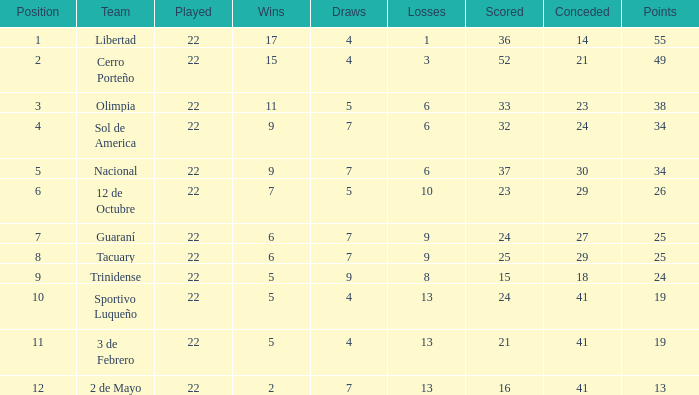Help me parse the entirety of this table. {'header': ['Position', 'Team', 'Played', 'Wins', 'Draws', 'Losses', 'Scored', 'Conceded', 'Points'], 'rows': [['1', 'Libertad', '22', '17', '4', '1', '36', '14', '55'], ['2', 'Cerro Porteño', '22', '15', '4', '3', '52', '21', '49'], ['3', 'Olimpia', '22', '11', '5', '6', '33', '23', '38'], ['4', 'Sol de America', '22', '9', '7', '6', '32', '24', '34'], ['5', 'Nacional', '22', '9', '7', '6', '37', '30', '34'], ['6', '12 de Octubre', '22', '7', '5', '10', '23', '29', '26'], ['7', 'Guaraní', '22', '6', '7', '9', '24', '27', '25'], ['8', 'Tacuary', '22', '6', '7', '9', '25', '29', '25'], ['9', 'Trinidense', '22', '5', '9', '8', '15', '18', '24'], ['10', 'Sportivo Luqueño', '22', '5', '4', '13', '24', '41', '19'], ['11', '3 de Febrero', '22', '5', '4', '13', '21', '41', '19'], ['12', '2 de Mayo', '22', '2', '7', '13', '16', '41', '13']]} For a team with more than 8 losses and a total of 13 points, what is their draw count? 7.0. 